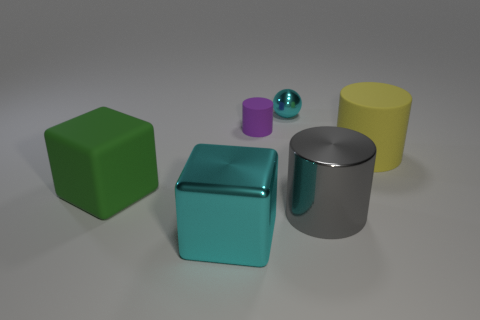There is a cylinder that is the same material as the purple object; what is its color? The cylinder that appears to be made of the same shiny material as the small purple object is actually silver in color, reflecting its environment with a chrome-like finish. 